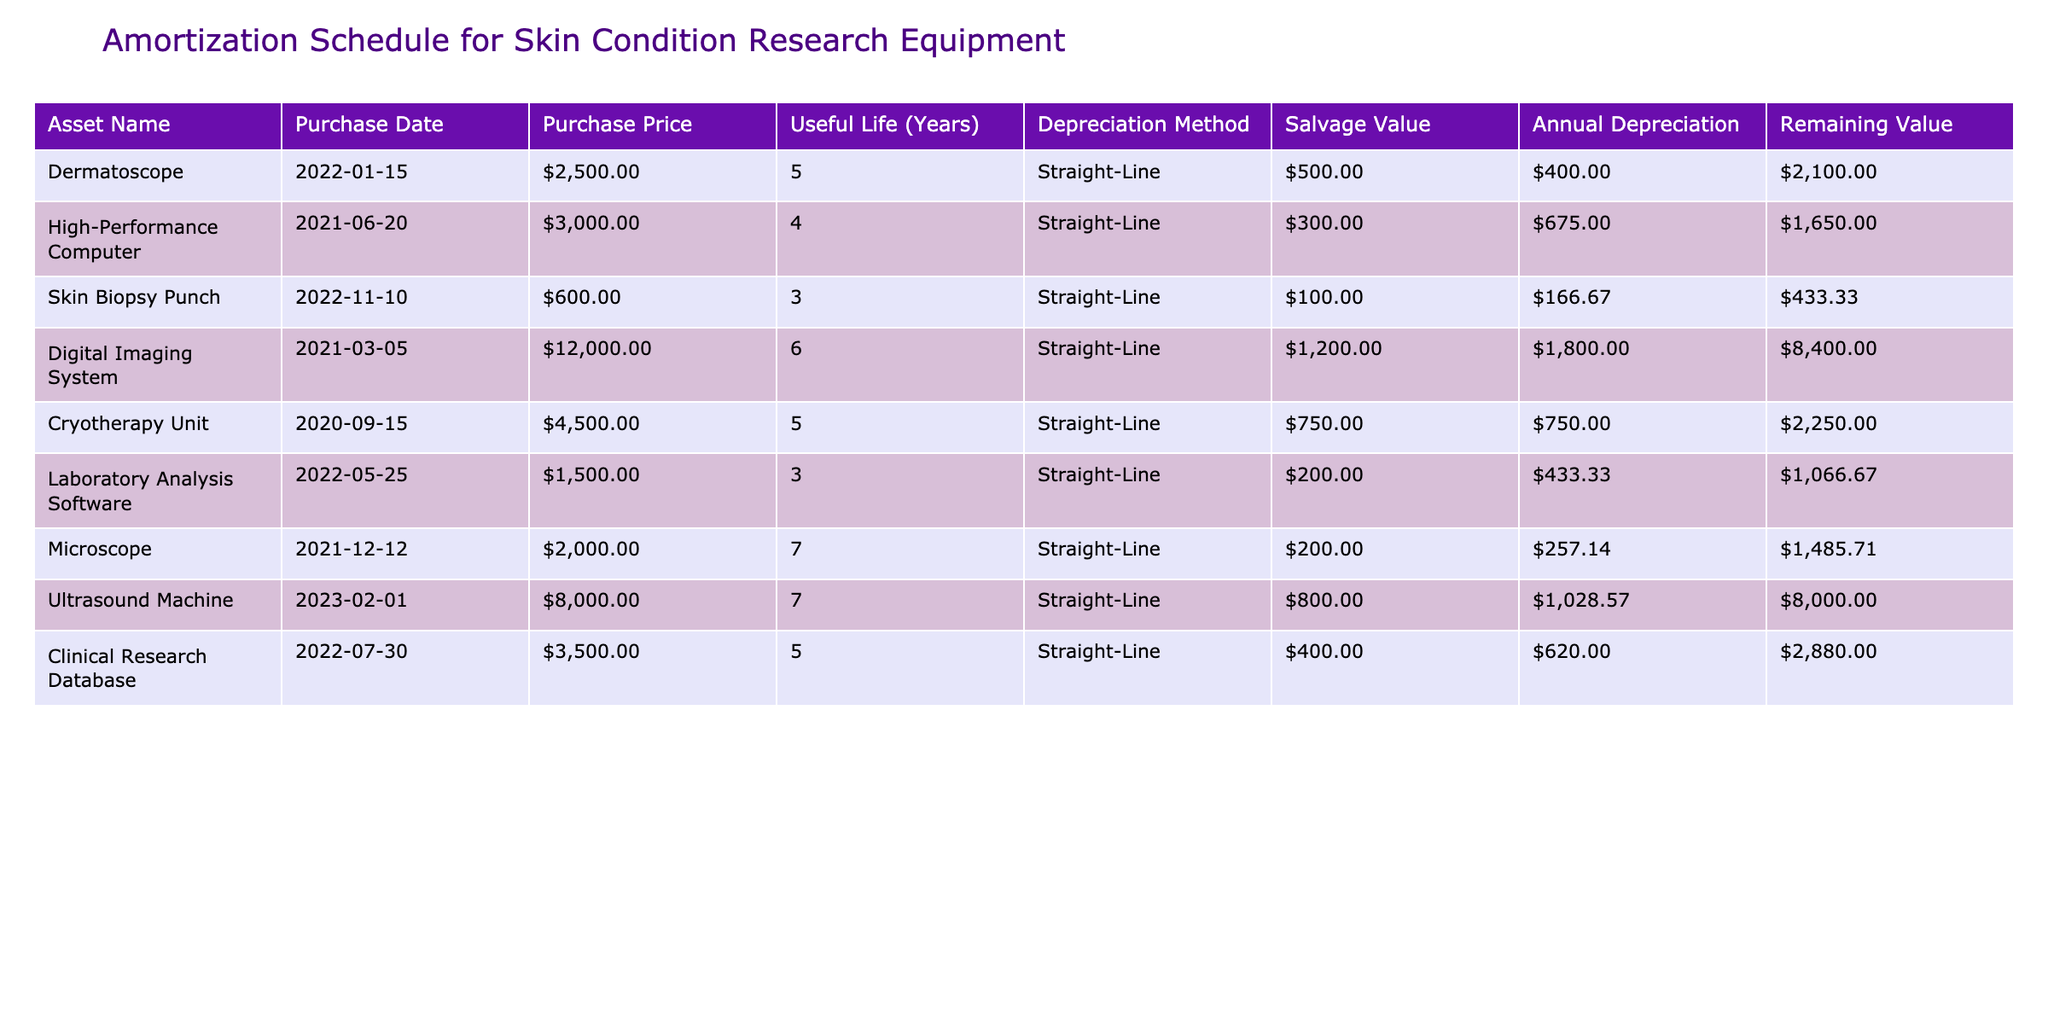What is the purchase price of the Digital Imaging System? The table lists the purchase price of each asset. The Digital Imaging System has a purchase price of $12,000.
Answer: $12,000 What is the annual depreciation for the Cryotherapy Unit? The annual depreciation is calculated by subtracting the salvage value from the purchase price and dividing by the useful life. For the Cryotherapy Unit, the calculation is ($4,500 - $750) / 5 years = $750.
Answer: $750 Which asset has the highest remaining value? The remaining value for each asset can be found in the corresponding column. Comparing the values, the Ultrasound Machine has the highest remaining value of $8,000.
Answer: $8,000 Is the salvage value of the Skin Biopsy Punch greater than its annual depreciation? The salvage value of the Skin Biopsy Punch is $100, while its annual depreciation is ($600 - $100) / 3 = $166.67. Since $100 is not greater than $166.67, the answer is no.
Answer: No What is the total annual depreciation for all assets listed? To find the total annual depreciation, add the annual depreciation for each asset: $500 + $750 + $166.67 + $1,900 + $750 + $433.33 + $257.14 + $1,142.86 + $560 = $6,510.00 (rounded).
Answer: $6,510.00 How many assets have a useful life of 5 years? From the table, the assets with a useful life of 5 years are the Dermatoscope, Cryotherapy Unit, and Clinical Research Database. There are 3 such assets.
Answer: 3 What is the remaining value of the High-Performance Computer as of 2023? The remaining value is determined as follows: the purchase price is $3,000, and the total depreciation over 2 years (2021-2022) is 2 * ($3,000 - $300) / 4 = $675. The remaining value is $3,000 - $675 = $2,325.
Answer: $2,325 Which asset has the longest useful life? The useful life for each asset can be compared directly. The Microscope has the longest useful life of 7 years.
Answer: 7 years 